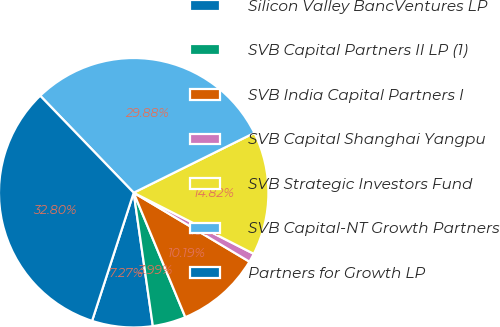Convert chart. <chart><loc_0><loc_0><loc_500><loc_500><pie_chart><fcel>Silicon Valley BancVentures LP<fcel>SVB Capital Partners II LP (1)<fcel>SVB India Capital Partners I<fcel>SVB Capital Shanghai Yangpu<fcel>SVB Strategic Investors Fund<fcel>SVB Capital-NT Growth Partners<fcel>Partners for Growth LP<nl><fcel>7.27%<fcel>3.99%<fcel>10.19%<fcel>1.06%<fcel>14.82%<fcel>29.88%<fcel>32.8%<nl></chart> 